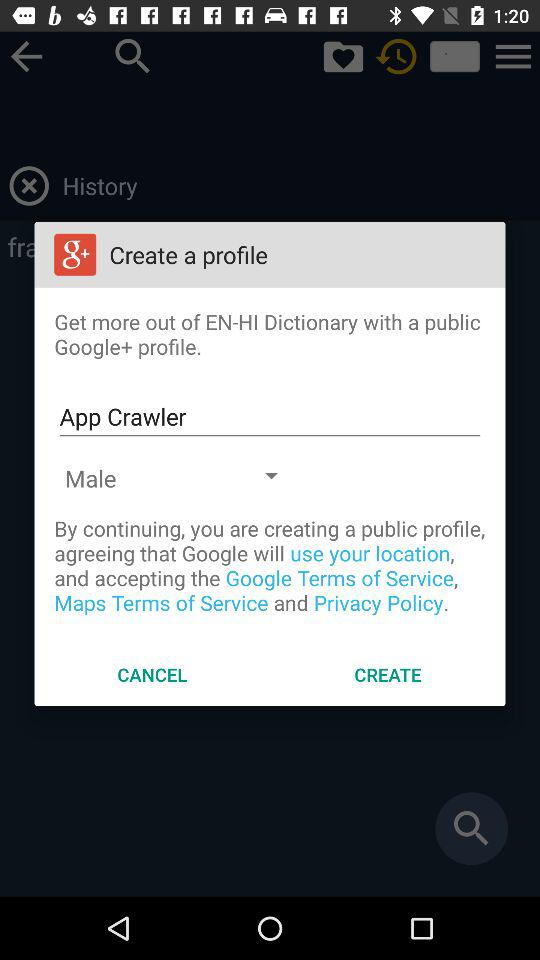What is the selected gender? The selected gender is male. 